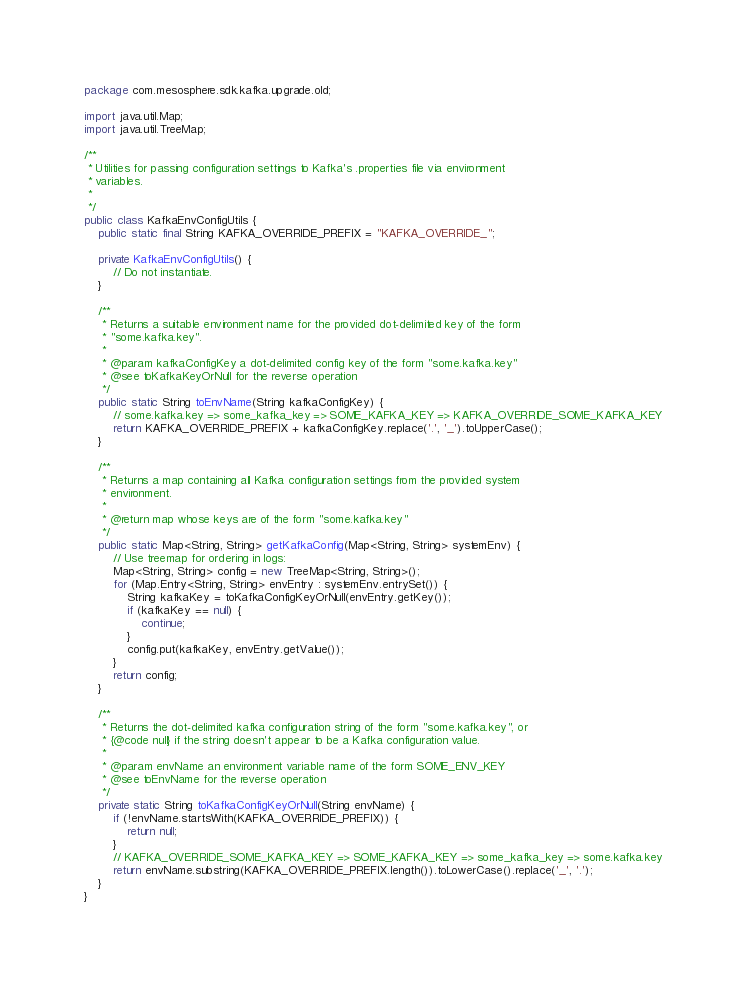Convert code to text. <code><loc_0><loc_0><loc_500><loc_500><_Java_>package com.mesosphere.sdk.kafka.upgrade.old;

import java.util.Map;
import java.util.TreeMap;

/**
 * Utilities for passing configuration settings to Kafka's .properties file via environment
 * variables.
 *
 */
public class KafkaEnvConfigUtils {
    public static final String KAFKA_OVERRIDE_PREFIX = "KAFKA_OVERRIDE_";

    private KafkaEnvConfigUtils() {
        // Do not instantiate.
    }

    /**
     * Returns a suitable environment name for the provided dot-delimited key of the form
     * "some.kafka.key".
     *
     * @param kafkaConfigKey a dot-delimited config key of the form "some.kafka.key"
     * @see toKafkaKeyOrNull for the reverse operation
     */
    public static String toEnvName(String kafkaConfigKey) {
        // some.kafka.key => some_kafka_key => SOME_KAFKA_KEY => KAFKA_OVERRIDE_SOME_KAFKA_KEY
        return KAFKA_OVERRIDE_PREFIX + kafkaConfigKey.replace('.', '_').toUpperCase();
    }

    /**
     * Returns a map containing all Kafka configuration settings from the provided system
     * environment.
     *
     * @return map whose keys are of the form "some.kafka.key"
     */
    public static Map<String, String> getKafkaConfig(Map<String, String> systemEnv) {
        // Use treemap for ordering in logs:
        Map<String, String> config = new TreeMap<String, String>();
        for (Map.Entry<String, String> envEntry : systemEnv.entrySet()) {
            String kafkaKey = toKafkaConfigKeyOrNull(envEntry.getKey());
            if (kafkaKey == null) {
                continue;
            }
            config.put(kafkaKey, envEntry.getValue());
        }
        return config;
    }

    /**
     * Returns the dot-delimited kafka configuration string of the form "some.kafka.key", or
     * {@code null} if the string doesn't appear to be a Kafka configuration value.
     *
     * @param envName an environment variable name of the form SOME_ENV_KEY
     * @see toEnvName for the reverse operation
     */
    private static String toKafkaConfigKeyOrNull(String envName) {
        if (!envName.startsWith(KAFKA_OVERRIDE_PREFIX)) {
            return null;
        }
        // KAFKA_OVERRIDE_SOME_KAFKA_KEY => SOME_KAFKA_KEY => some_kafka_key => some.kafka.key
        return envName.substring(KAFKA_OVERRIDE_PREFIX.length()).toLowerCase().replace('_', '.');
    }
}
</code> 